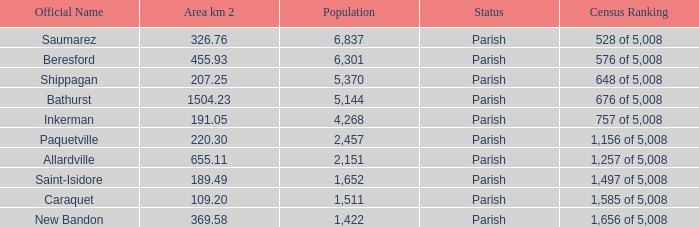What is the Area of the Allardville Parish with a Population smaller than 2,151? None. 